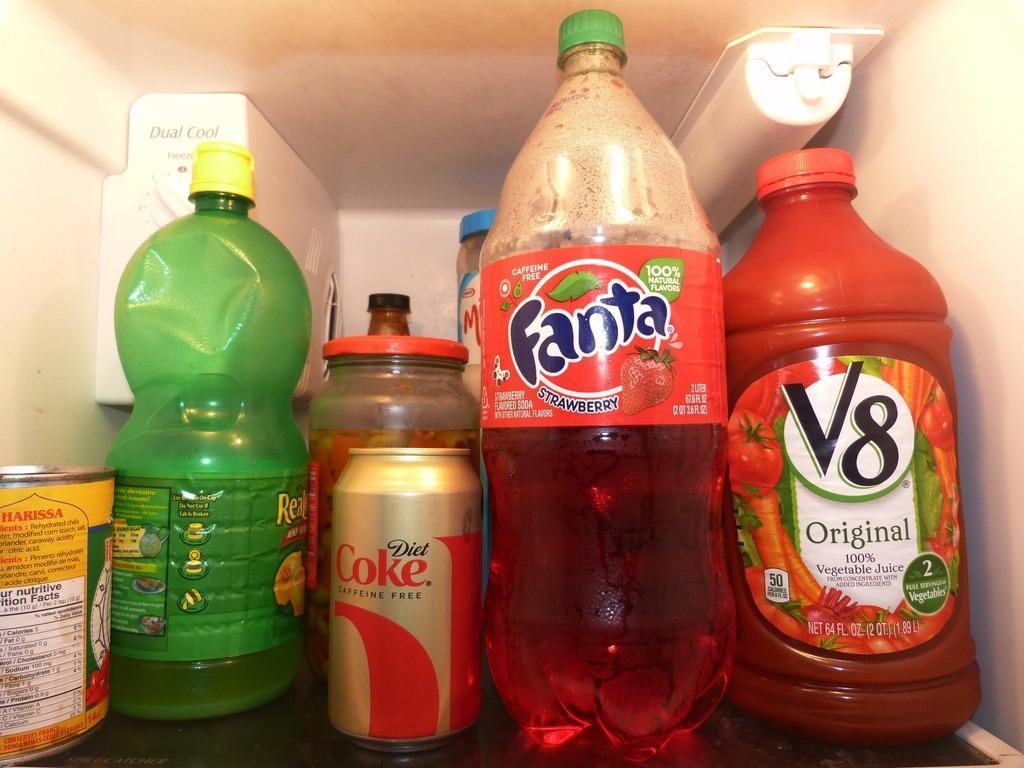Could you give a brief overview of what you see in this image? This picture shows few bottles and a tin in the refrigerator 